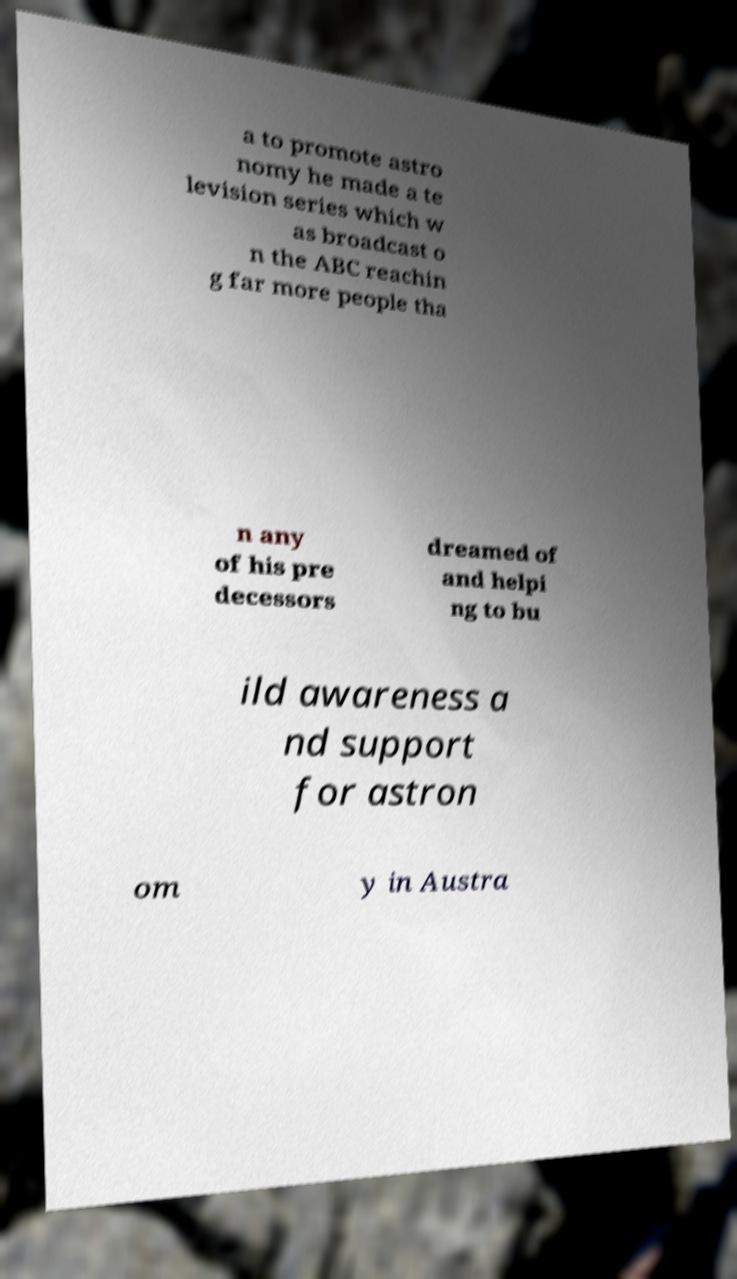Can you read and provide the text displayed in the image?This photo seems to have some interesting text. Can you extract and type it out for me? a to promote astro nomy he made a te levision series which w as broadcast o n the ABC reachin g far more people tha n any of his pre decessors dreamed of and helpi ng to bu ild awareness a nd support for astron om y in Austra 